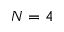<formula> <loc_0><loc_0><loc_500><loc_500>N = 4</formula> 